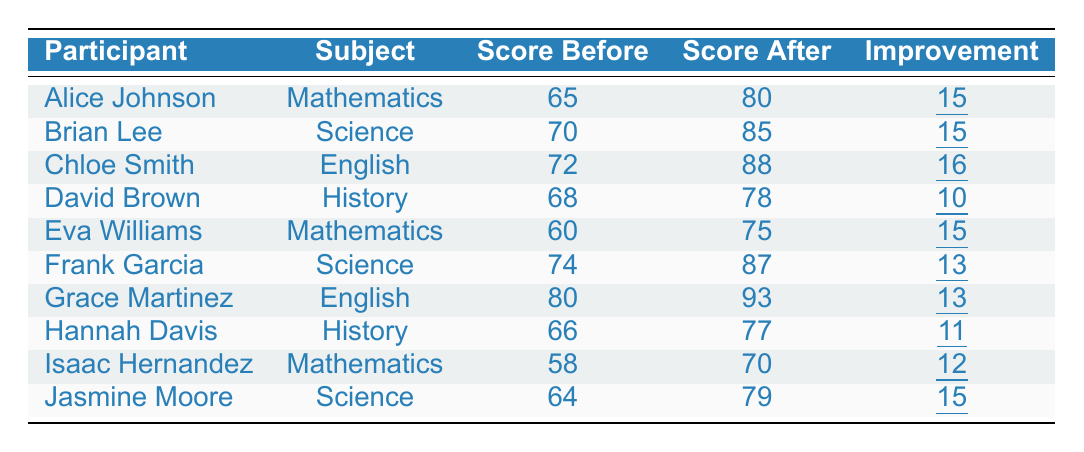What was the highest score improvement among the participants? The highest improvement in scores can be found by looking at the 'Improvement' column in the table. Chloe Smith improved by 16 points, which is the largest value in that column.
Answer: 16 Which subject had the participant with the lowest score before training? By examining the 'Score Before' column, Isaac Hernandez had the lowest score of 58 in Mathematics before the training.
Answer: Mathematics How many participants improved their scores by 15 points? In the 'Improvement' column, there are three participants: Alice Johnson, Brian Lee, and Jasmine Moore, who each improved their scores by 15 points.
Answer: 3 What is the average improvement in the scores of all participants? To find the average, we sum all the improvements: (15 + 15 + 16 + 10 + 15 + 13 + 13 + 11 + 12 + 15) = 15, and divide by the number of participants (10): 15/10 = 15.
Answer: 15 Did any participant score lower after training compared to their score before? Reviewing the 'Score After' column against the 'Score Before' column reveals that all participants scored higher after the training, confirming that no participant scored lower.
Answer: No Which subject had the largest average improvement in scores? To find this, we need to calculate the average improvement for each subject: Mathematics (15.33), Science (14.33), English (14.5), History (10.5). Mathematics has the highest average with 15.33.
Answer: Mathematics Who achieved the highest score after the training? By checking the 'Score After' column, Chloe Smith scored 88, which is the highest score among all participants after the training.
Answer: 88 How much did Eva Williams improve her score? Eva Williams' improvement is directly stated in the ‘Improvement’ column as 15.
Answer: 15 Which two subjects had the same score improvement of 13 points? Looking at the 'Improvement' column, both Frank Garcia (Science) and Grace Martinez (English) improved their scores by 13 points.
Answer: Science and English Are there more participants who improved their scores by 12 points or 11 points? There is one participant (Isaac Hernandez) with a 12-point improvement, while two participants (Hannah Davis and Frank Garcia) each improved by 11 points, indicating there are more with 11 points.
Answer: 11 points 